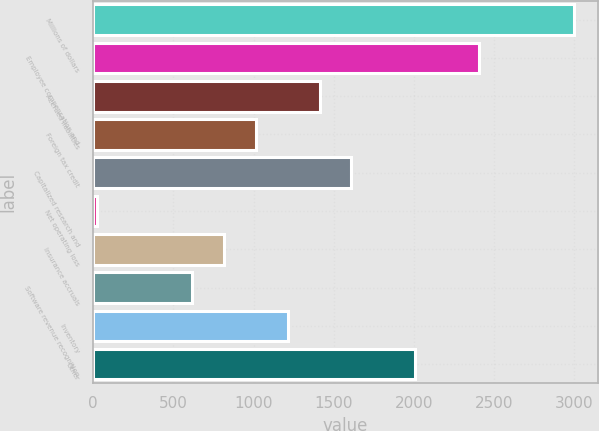Convert chart to OTSL. <chart><loc_0><loc_0><loc_500><loc_500><bar_chart><fcel>Millions of dollars<fcel>Employee compensation and<fcel>Accrued liabilities<fcel>Foreign tax credit<fcel>Capitalized research and<fcel>Net operating loss<fcel>Insurance accruals<fcel>Software revenue recognition<fcel>Inventory<fcel>Other<nl><fcel>2998.5<fcel>2403.6<fcel>1412.1<fcel>1015.5<fcel>1610.4<fcel>24<fcel>817.2<fcel>618.9<fcel>1213.8<fcel>2007<nl></chart> 